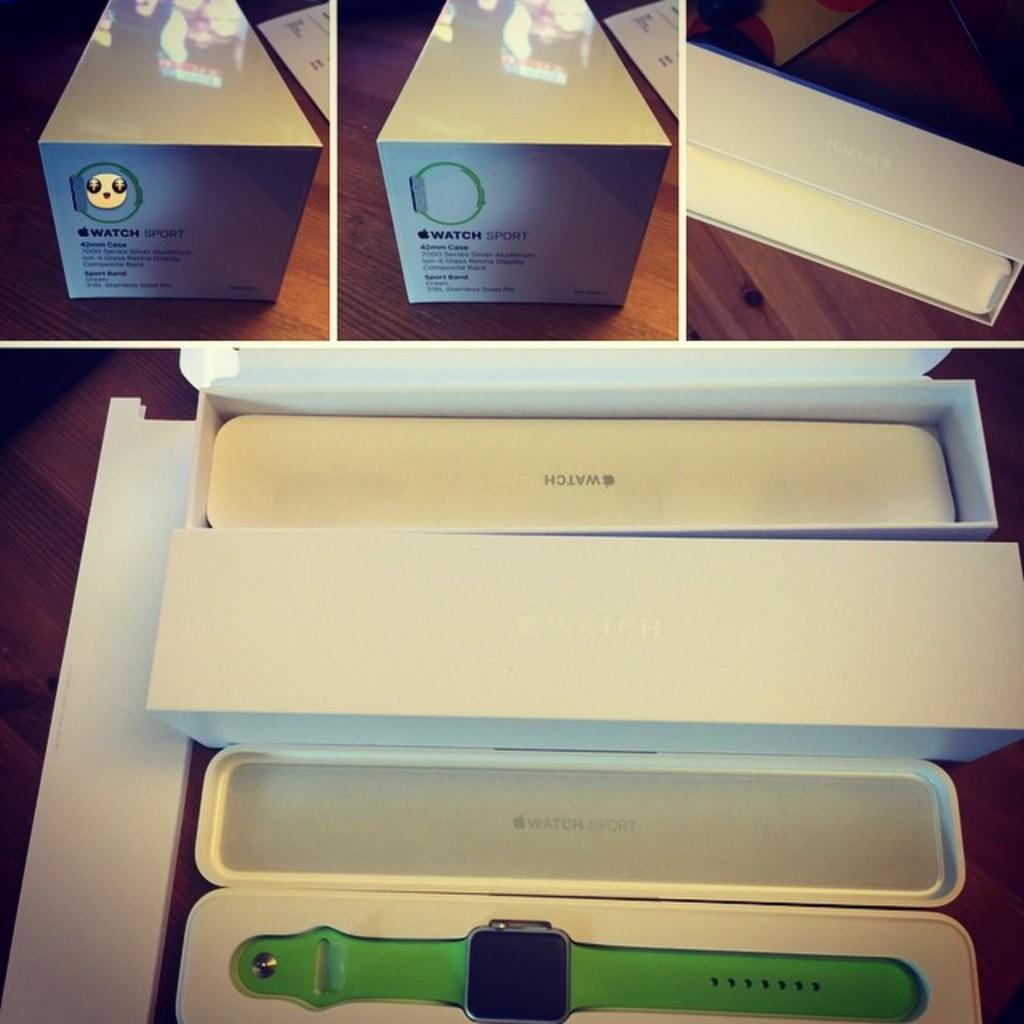<image>
Summarize the visual content of the image. A box with a green Apple Watch inside it. 